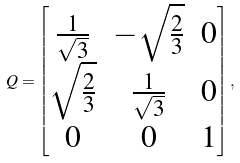<formula> <loc_0><loc_0><loc_500><loc_500>Q = \begin{bmatrix} \frac { 1 } { \sqrt { 3 } } & - \sqrt { \frac { 2 } { 3 } } & 0 \\ \sqrt { \frac { 2 } { 3 } } & \frac { 1 } { \sqrt { 3 } } & 0 \\ 0 & 0 & 1 \\ \end{bmatrix} ,</formula> 